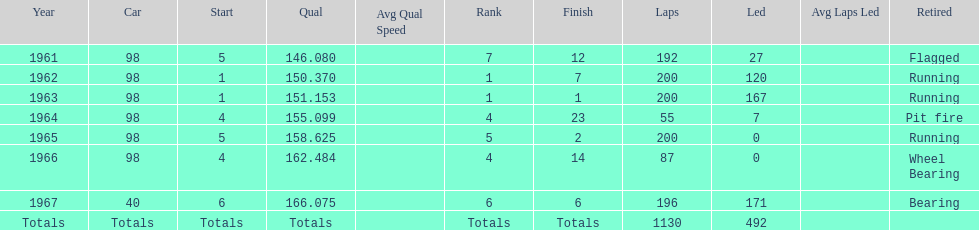How many total laps have been driven in the indy 500? 1130. 